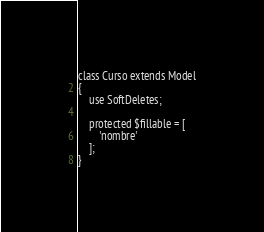Convert code to text. <code><loc_0><loc_0><loc_500><loc_500><_PHP_>class Curso extends Model
{
    use SoftDeletes;

    protected $fillable = [
        'nombre'
    ];
}
</code> 